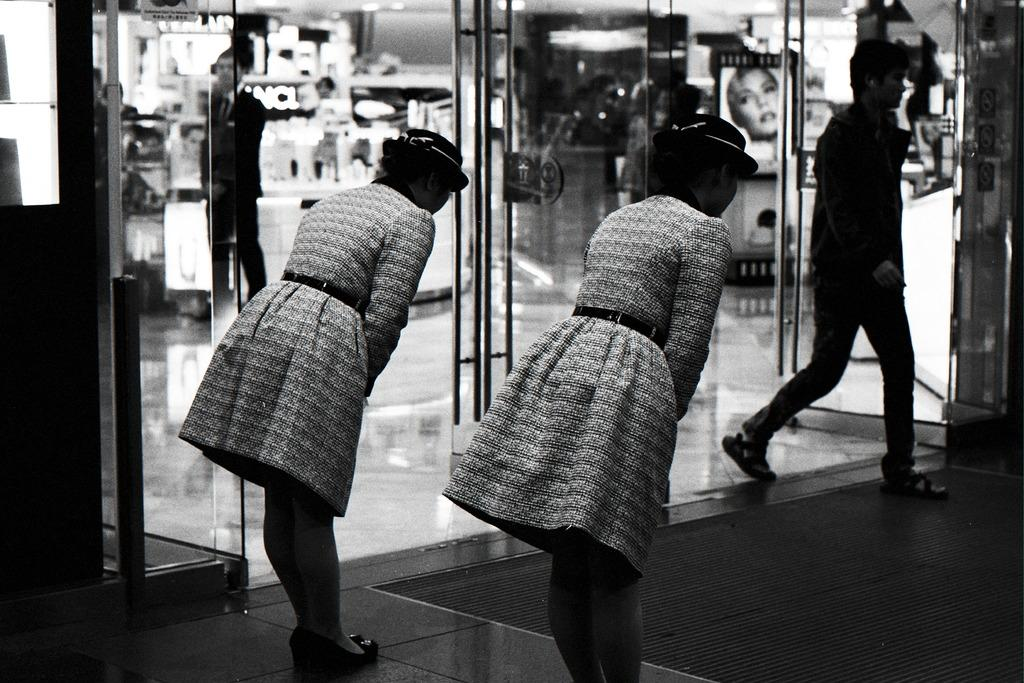What is the color scheme of the image? The image is black and white. Who or what can be seen in the image? There are people in the image. What type of architectural feature is present in the image? There are glass doors in the image. What can be seen through the glass doors? Objects are visible through the glass doors. What type of decorative items are present in the image? There are posters in the image. What type of meat is being served in the image? There is no meat present in the image. What form does the railway take in the image? There is no railway present in the image. 